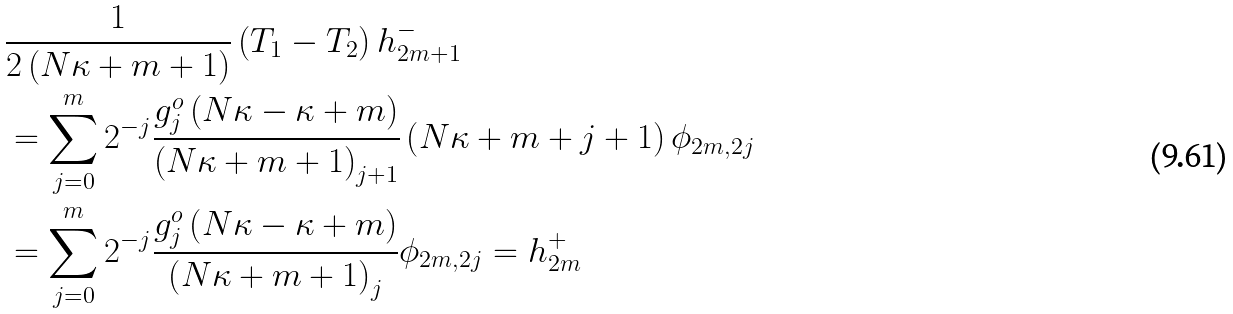Convert formula to latex. <formula><loc_0><loc_0><loc_500><loc_500>& \frac { 1 } { 2 \left ( N \kappa + m + 1 \right ) } \left ( T _ { 1 } - T _ { 2 } \right ) h _ { 2 m + 1 } ^ { - } \\ & = \sum _ { j = 0 } ^ { m } 2 ^ { - j } \frac { g _ { j } ^ { o } \left ( N \kappa - \kappa + m \right ) } { \left ( N \kappa + m + 1 \right ) _ { j + 1 } } \left ( N \kappa + m + j + 1 \right ) \phi _ { 2 m , 2 j } \\ & = \sum _ { j = 0 } ^ { m } 2 ^ { - j } \frac { g _ { j } ^ { o } \left ( N \kappa - \kappa + m \right ) } { \left ( N \kappa + m + 1 \right ) _ { j } } \phi _ { 2 m , 2 j } = h _ { 2 m } ^ { + }</formula> 